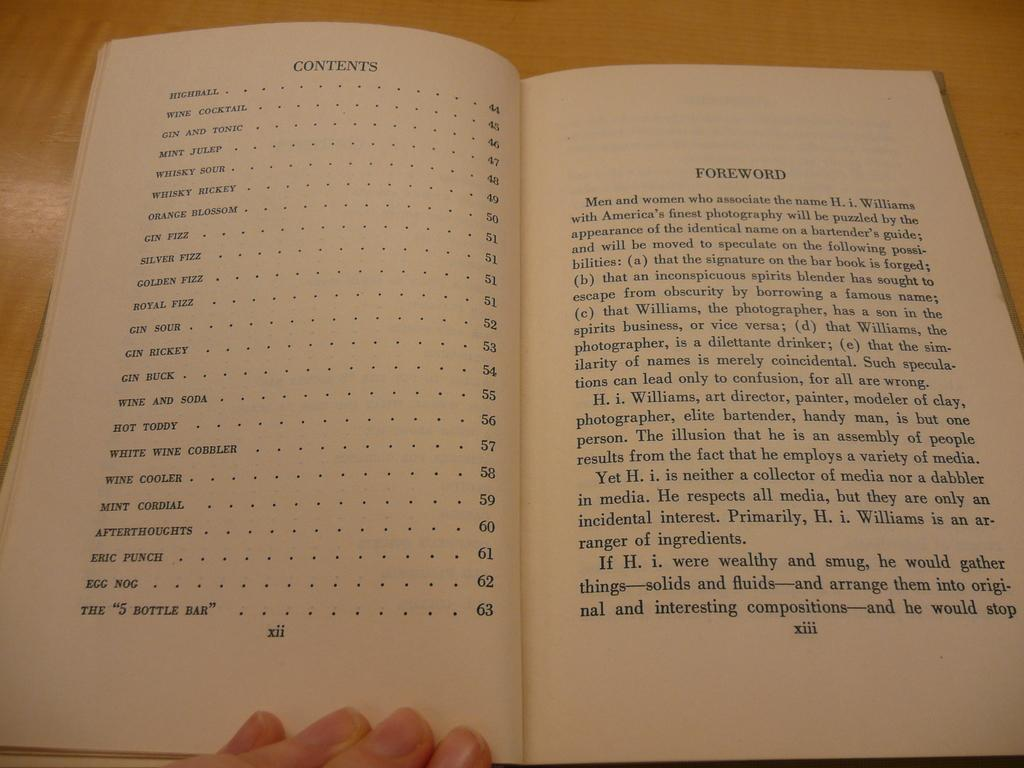<image>
Create a compact narrative representing the image presented. A person is reading a book that is open to the contents and foreword. 